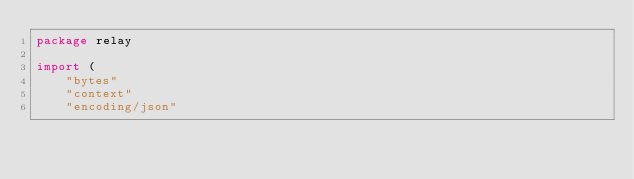<code> <loc_0><loc_0><loc_500><loc_500><_Go_>package relay

import (
	"bytes"
	"context"
	"encoding/json"</code> 